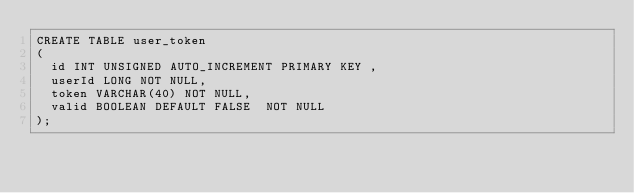Convert code to text. <code><loc_0><loc_0><loc_500><loc_500><_SQL_>CREATE TABLE user_token
(
  id INT UNSIGNED AUTO_INCREMENT PRIMARY KEY ,
  userId LONG NOT NULL,
  token VARCHAR(40) NOT NULL,
  valid BOOLEAN DEFAULT FALSE  NOT NULL
);</code> 